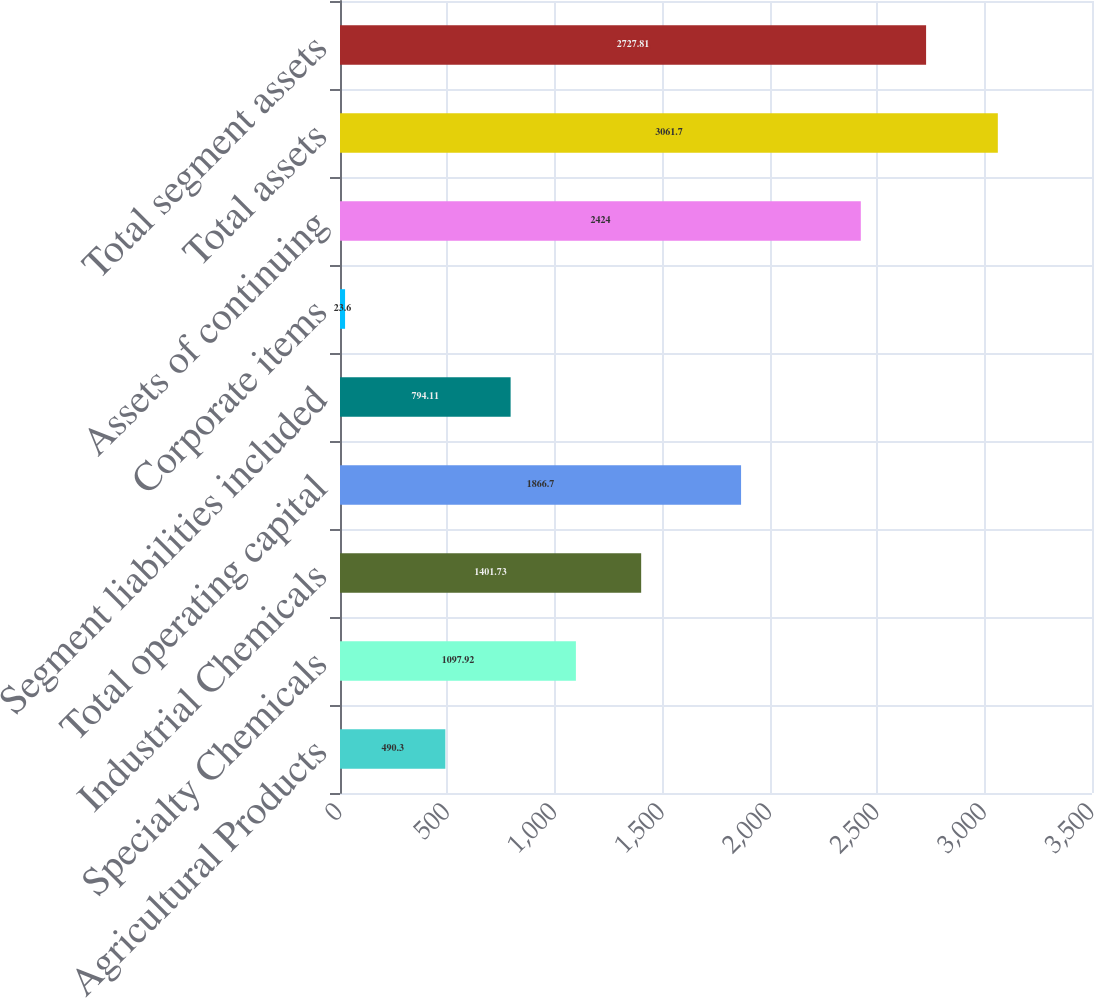Convert chart to OTSL. <chart><loc_0><loc_0><loc_500><loc_500><bar_chart><fcel>Agricultural Products<fcel>Specialty Chemicals<fcel>Industrial Chemicals<fcel>Total operating capital<fcel>Segment liabilities included<fcel>Corporate items<fcel>Assets of continuing<fcel>Total assets<fcel>Total segment assets<nl><fcel>490.3<fcel>1097.92<fcel>1401.73<fcel>1866.7<fcel>794.11<fcel>23.6<fcel>2424<fcel>3061.7<fcel>2727.81<nl></chart> 